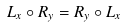<formula> <loc_0><loc_0><loc_500><loc_500>L _ { x } \circ R _ { y } = R _ { y } \circ L _ { x }</formula> 